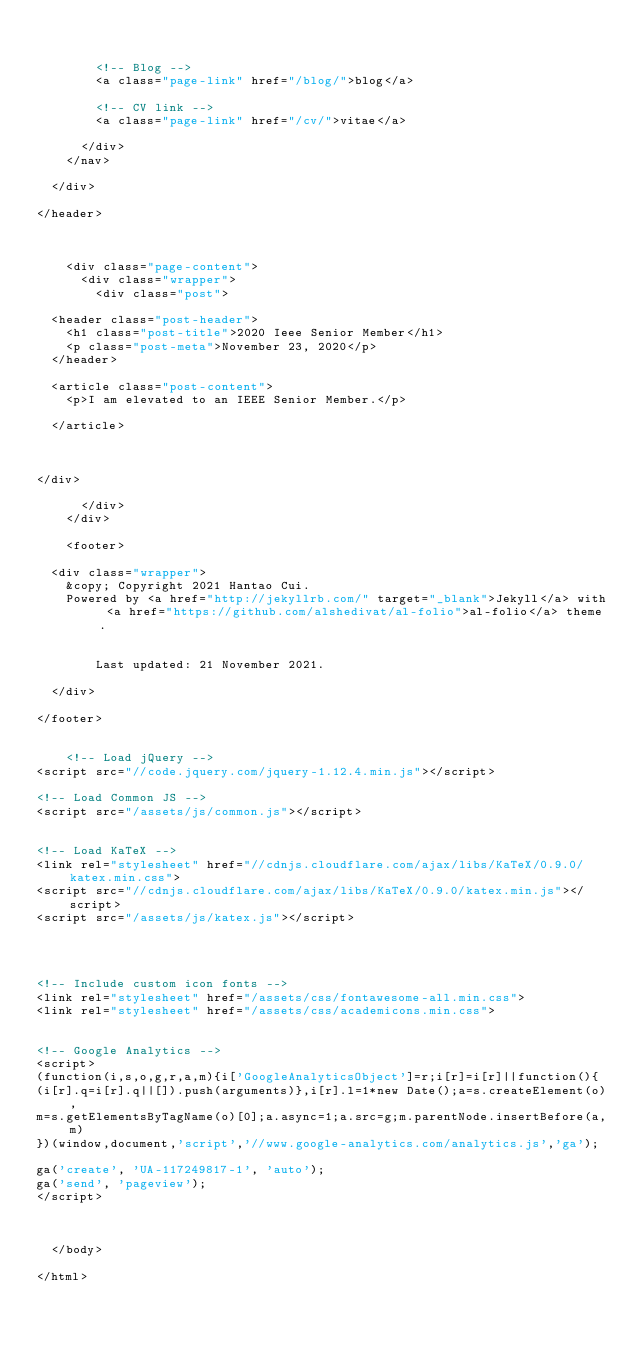Convert code to text. <code><loc_0><loc_0><loc_500><loc_500><_HTML_>        

        <!-- Blog -->
        <a class="page-link" href="/blog/">blog</a>

        <!-- CV link -->
        <a class="page-link" href="/cv/">vitae</a>

      </div>
    </nav>

  </div>

</header>



    <div class="page-content">
      <div class="wrapper">
        <div class="post">

  <header class="post-header">
    <h1 class="post-title">2020 Ieee Senior Member</h1>
    <p class="post-meta">November 23, 2020</p>
  </header>

  <article class="post-content">
    <p>I am elevated to an IEEE Senior Member.</p>

  </article>

  

</div>

      </div>
    </div>

    <footer>

  <div class="wrapper">
    &copy; Copyright 2021 Hantao Cui.
    Powered by <a href="http://jekyllrb.com/" target="_blank">Jekyll</a> with <a href="https://github.com/alshedivat/al-folio">al-folio</a> theme.

    
        Last updated: 21 November 2021.
    
  </div>

</footer>


    <!-- Load jQuery -->
<script src="//code.jquery.com/jquery-1.12.4.min.js"></script>

<!-- Load Common JS -->
<script src="/assets/js/common.js"></script>


<!-- Load KaTeX -->
<link rel="stylesheet" href="//cdnjs.cloudflare.com/ajax/libs/KaTeX/0.9.0/katex.min.css">
<script src="//cdnjs.cloudflare.com/ajax/libs/KaTeX/0.9.0/katex.min.js"></script>
<script src="/assets/js/katex.js"></script>




<!-- Include custom icon fonts -->
<link rel="stylesheet" href="/assets/css/fontawesome-all.min.css">
<link rel="stylesheet" href="/assets/css/academicons.min.css">


<!-- Google Analytics -->
<script>
(function(i,s,o,g,r,a,m){i['GoogleAnalyticsObject']=r;i[r]=i[r]||function(){
(i[r].q=i[r].q||[]).push(arguments)},i[r].l=1*new Date();a=s.createElement(o),
m=s.getElementsByTagName(o)[0];a.async=1;a.src=g;m.parentNode.insertBefore(a,m)
})(window,document,'script','//www.google-analytics.com/analytics.js','ga');

ga('create', 'UA-117249817-1', 'auto');
ga('send', 'pageview');
</script>



  </body>

</html>
</code> 